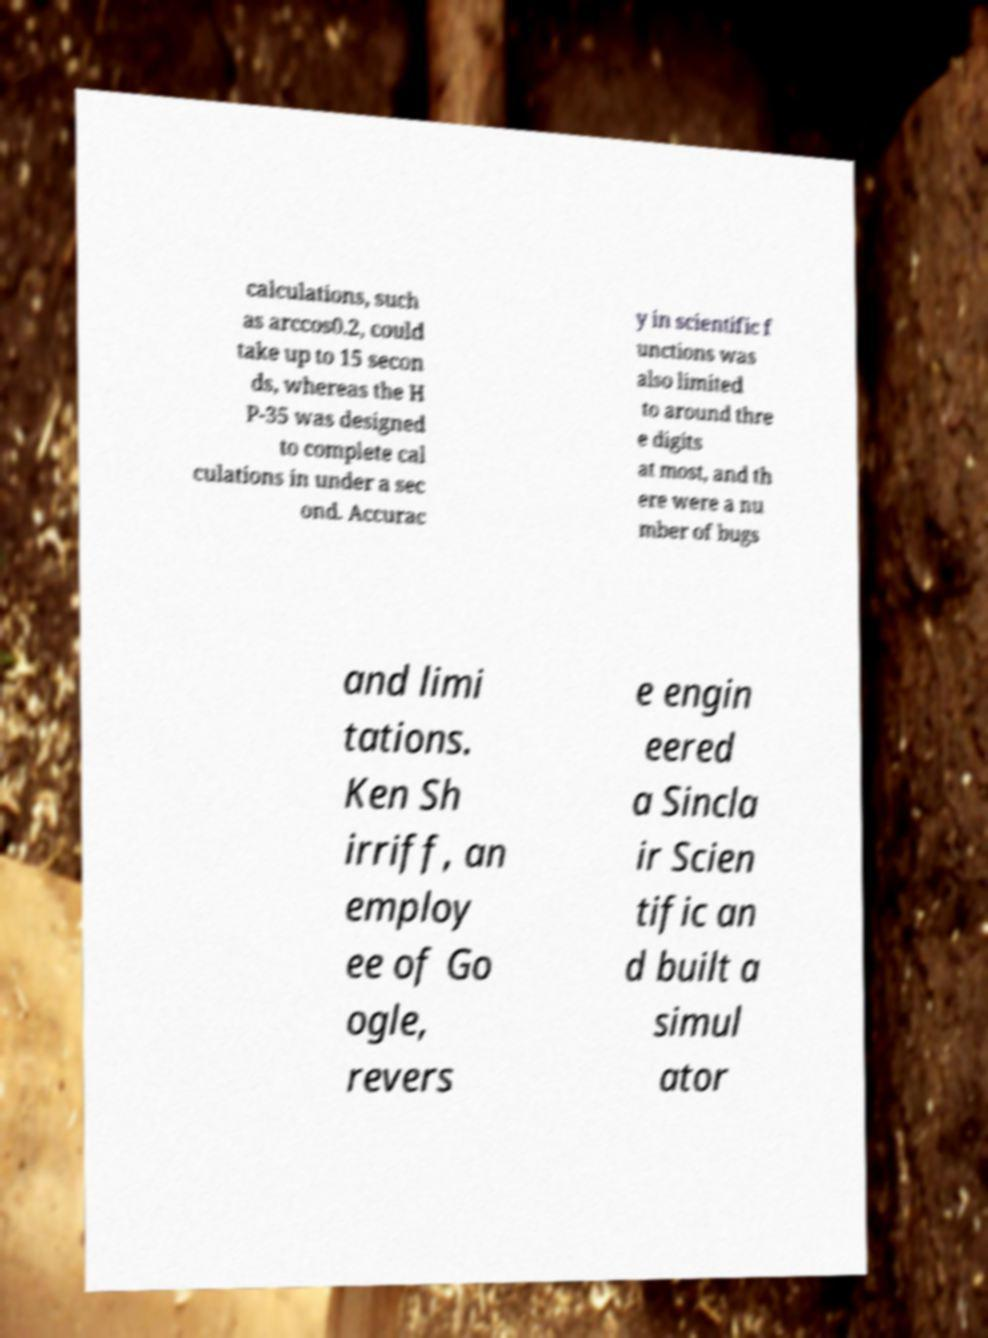Can you accurately transcribe the text from the provided image for me? calculations, such as arccos0.2, could take up to 15 secon ds, whereas the H P-35 was designed to complete cal culations in under a sec ond. Accurac y in scientific f unctions was also limited to around thre e digits at most, and th ere were a nu mber of bugs and limi tations. Ken Sh irriff, an employ ee of Go ogle, revers e engin eered a Sincla ir Scien tific an d built a simul ator 